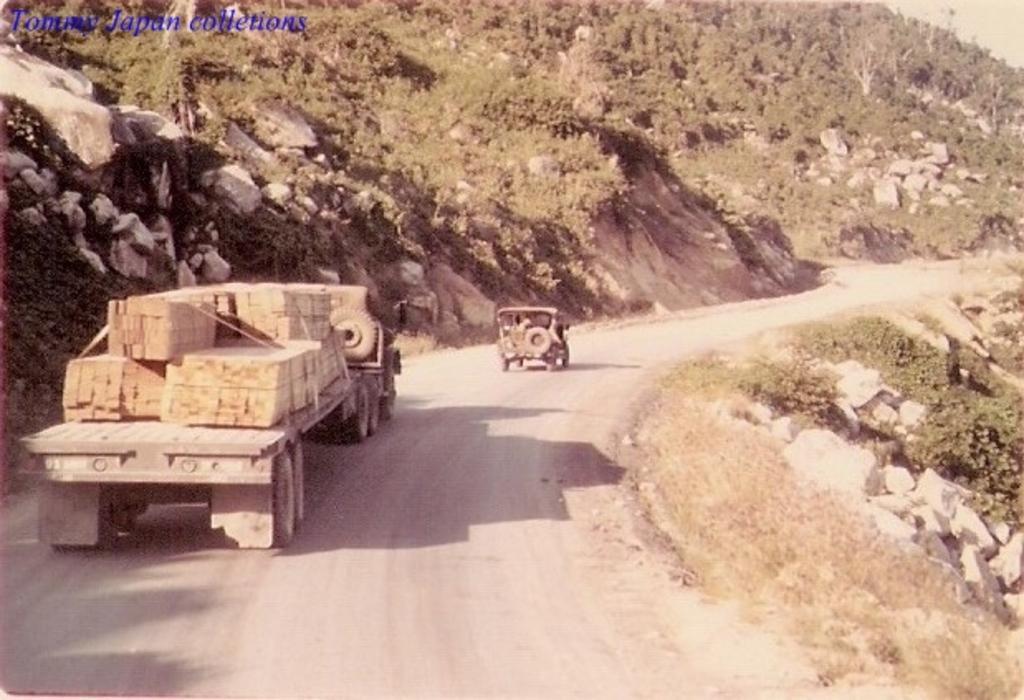In one or two sentences, can you explain what this image depicts? There is a road. On the road there are vehicles. On the vehicle there are goods. On the sides of the road there are rocks and plants. In the top left corner there is a watermark. 